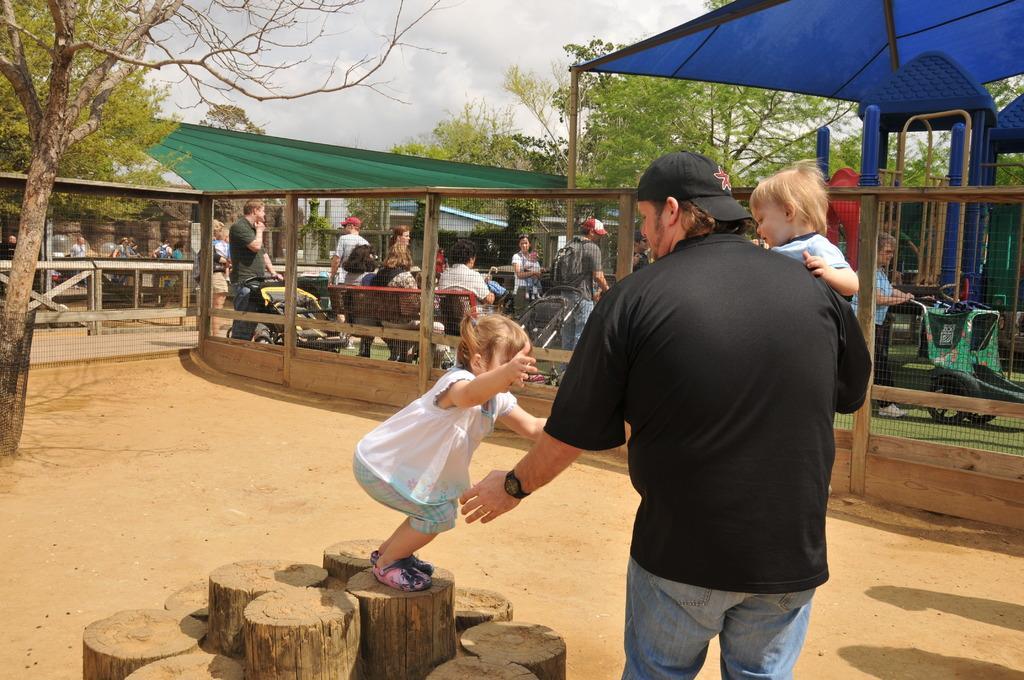How would you summarize this image in a sentence or two? In the center of the image we can see person holding a baby and person standing on the wood. On the left side of the image we can see trees. In the background we can see fencing, vehicles, benches, persons, tent, trees, sky and clouds. 